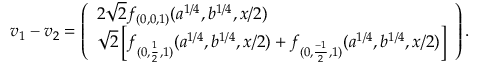Convert formula to latex. <formula><loc_0><loc_0><loc_500><loc_500>\begin{array} { r } { v _ { 1 } - v _ { 2 } = \left ( \begin{array} { l } { 2 \sqrt { 2 } f _ { ( 0 , 0 , 1 ) } ( a ^ { 1 / 4 } , b ^ { 1 / 4 } , x / 2 ) } \\ { \sqrt { 2 } \left [ f _ { ( 0 , \frac { 1 } { 2 } , 1 ) } ( a ^ { 1 / 4 } , b ^ { 1 / 4 } , x / 2 ) + f _ { ( 0 , \frac { - 1 } { 2 } , 1 ) } ( a ^ { 1 / 4 } , b ^ { 1 / 4 } , x / 2 ) \right ] } \end{array} \right ) . } \end{array}</formula> 